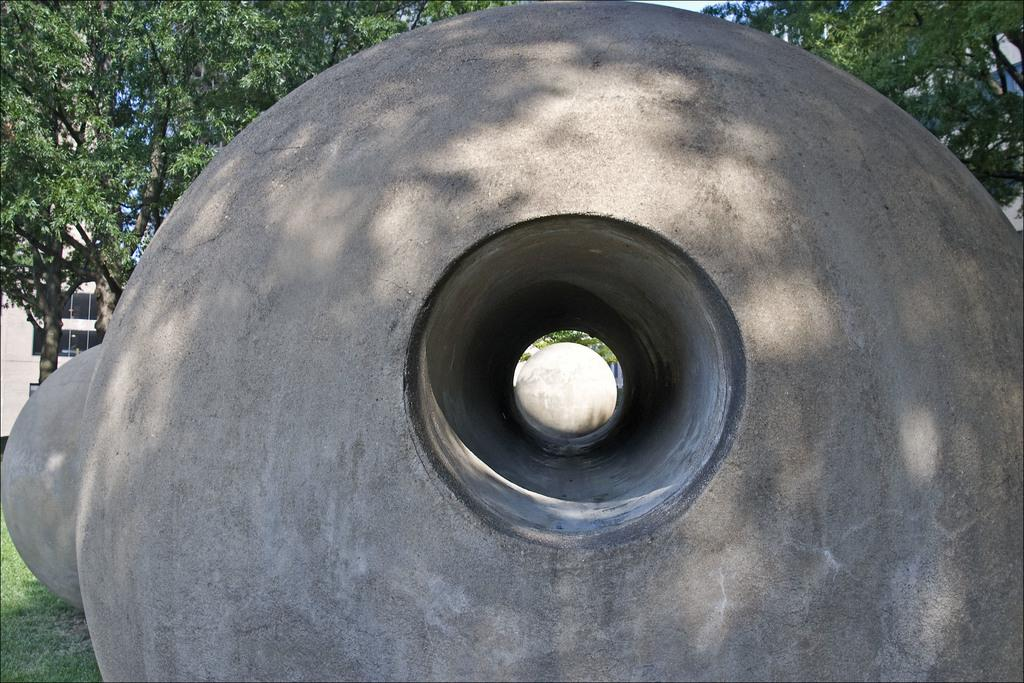What is the main subject in the center of the image? There are round shape solid structures in the center of the image. What can be seen in the background of the image? There are trees, one building, and grass in the background of the image. How does the stomach of the person in the image feel after eating the solid structures? There is no person present in the image, and therefore no stomach or eating activity can be observed. 